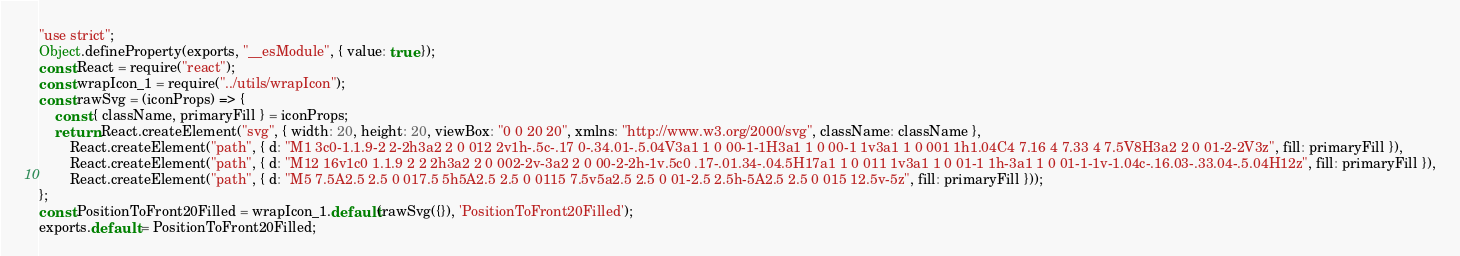Convert code to text. <code><loc_0><loc_0><loc_500><loc_500><_JavaScript_>"use strict";
Object.defineProperty(exports, "__esModule", { value: true });
const React = require("react");
const wrapIcon_1 = require("../utils/wrapIcon");
const rawSvg = (iconProps) => {
    const { className, primaryFill } = iconProps;
    return React.createElement("svg", { width: 20, height: 20, viewBox: "0 0 20 20", xmlns: "http://www.w3.org/2000/svg", className: className },
        React.createElement("path", { d: "M1 3c0-1.1.9-2 2-2h3a2 2 0 012 2v1h-.5c-.17 0-.34.01-.5.04V3a1 1 0 00-1-1H3a1 1 0 00-1 1v3a1 1 0 001 1h1.04C4 7.16 4 7.33 4 7.5V8H3a2 2 0 01-2-2V3z", fill: primaryFill }),
        React.createElement("path", { d: "M12 16v1c0 1.1.9 2 2 2h3a2 2 0 002-2v-3a2 2 0 00-2-2h-1v.5c0 .17-.01.34-.04.5H17a1 1 0 011 1v3a1 1 0 01-1 1h-3a1 1 0 01-1-1v-1.04c-.16.03-.33.04-.5.04H12z", fill: primaryFill }),
        React.createElement("path", { d: "M5 7.5A2.5 2.5 0 017.5 5h5A2.5 2.5 0 0115 7.5v5a2.5 2.5 0 01-2.5 2.5h-5A2.5 2.5 0 015 12.5v-5z", fill: primaryFill }));
};
const PositionToFront20Filled = wrapIcon_1.default(rawSvg({}), 'PositionToFront20Filled');
exports.default = PositionToFront20Filled;
</code> 